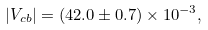Convert formula to latex. <formula><loc_0><loc_0><loc_500><loc_500>| V _ { c b } | = ( 4 2 . 0 \pm 0 . 7 ) \times 1 0 ^ { - 3 } ,</formula> 